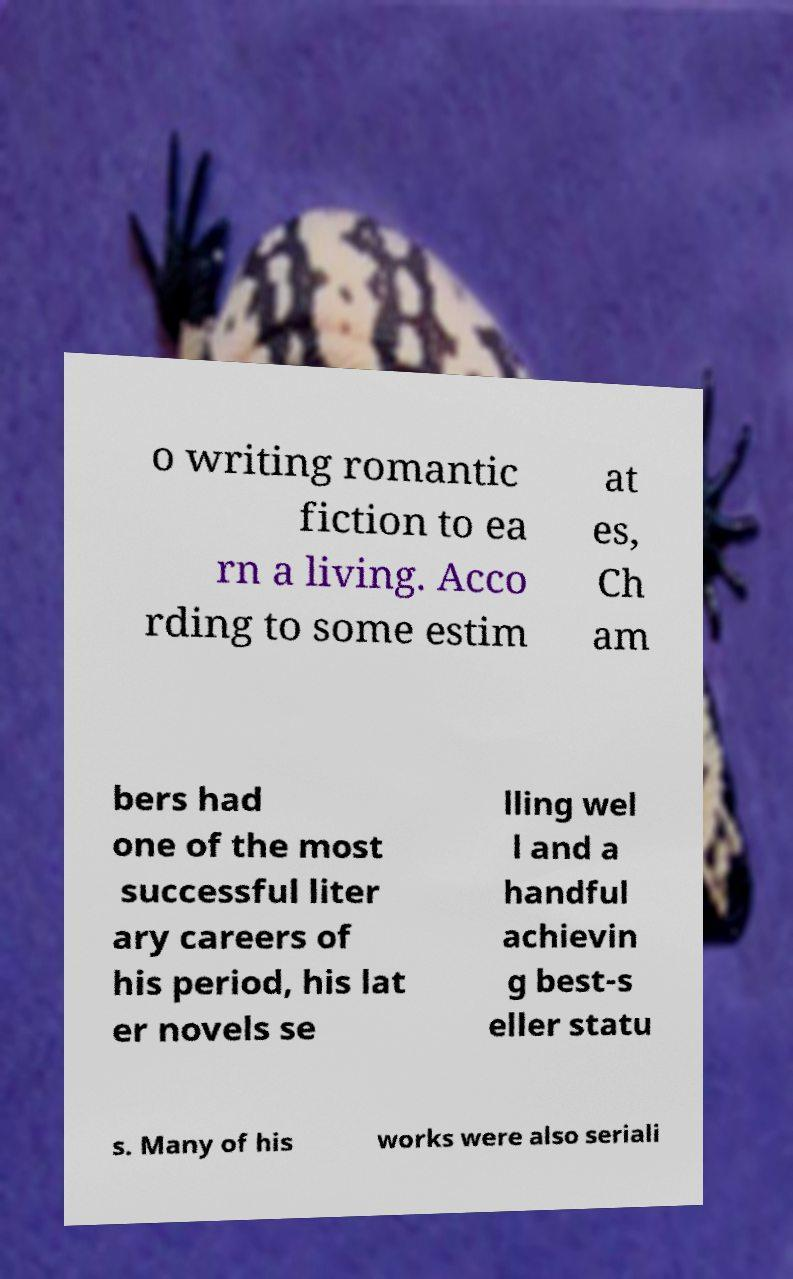Could you assist in decoding the text presented in this image and type it out clearly? o writing romantic fiction to ea rn a living. Acco rding to some estim at es, Ch am bers had one of the most successful liter ary careers of his period, his lat er novels se lling wel l and a handful achievin g best-s eller statu s. Many of his works were also seriali 